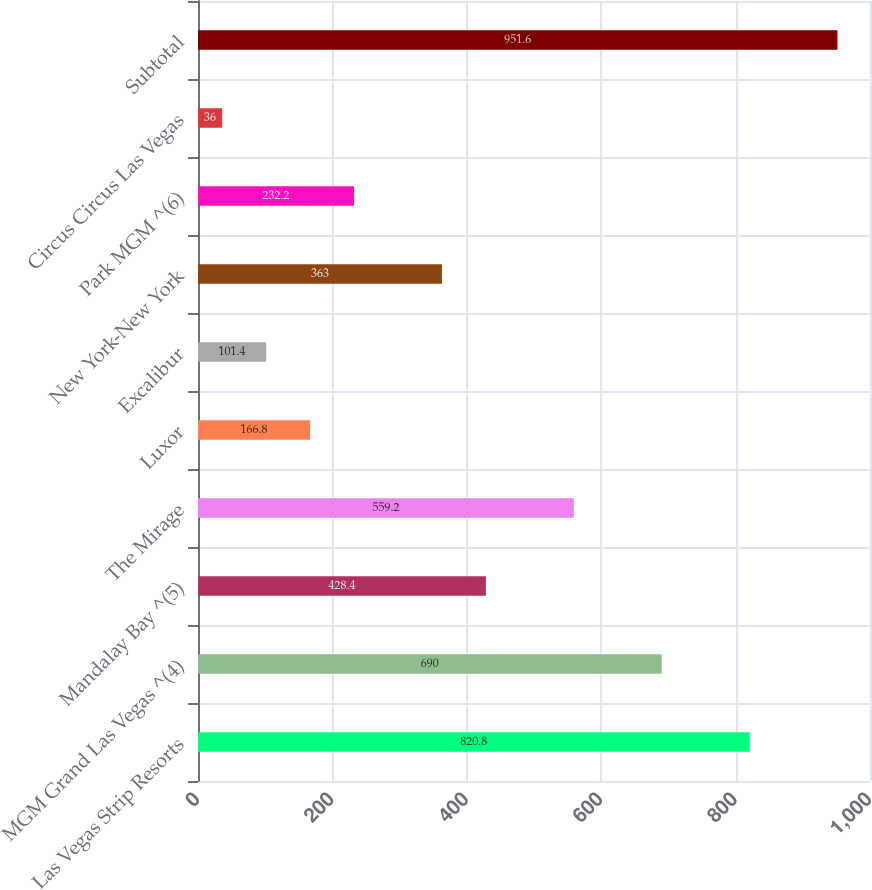Convert chart to OTSL. <chart><loc_0><loc_0><loc_500><loc_500><bar_chart><fcel>Las Vegas Strip Resorts<fcel>MGM Grand Las Vegas ^(4)<fcel>Mandalay Bay ^(5)<fcel>The Mirage<fcel>Luxor<fcel>Excalibur<fcel>New York-New York<fcel>Park MGM ^(6)<fcel>Circus Circus Las Vegas<fcel>Subtotal<nl><fcel>820.8<fcel>690<fcel>428.4<fcel>559.2<fcel>166.8<fcel>101.4<fcel>363<fcel>232.2<fcel>36<fcel>951.6<nl></chart> 